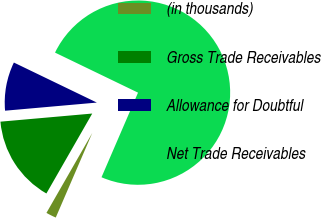Convert chart. <chart><loc_0><loc_0><loc_500><loc_500><pie_chart><fcel>(in thousands)<fcel>Gross Trade Receivables<fcel>Allowance for Doubtful<fcel>Net Trade Receivables<nl><fcel>1.8%<fcel>15.31%<fcel>8.56%<fcel>74.33%<nl></chart> 